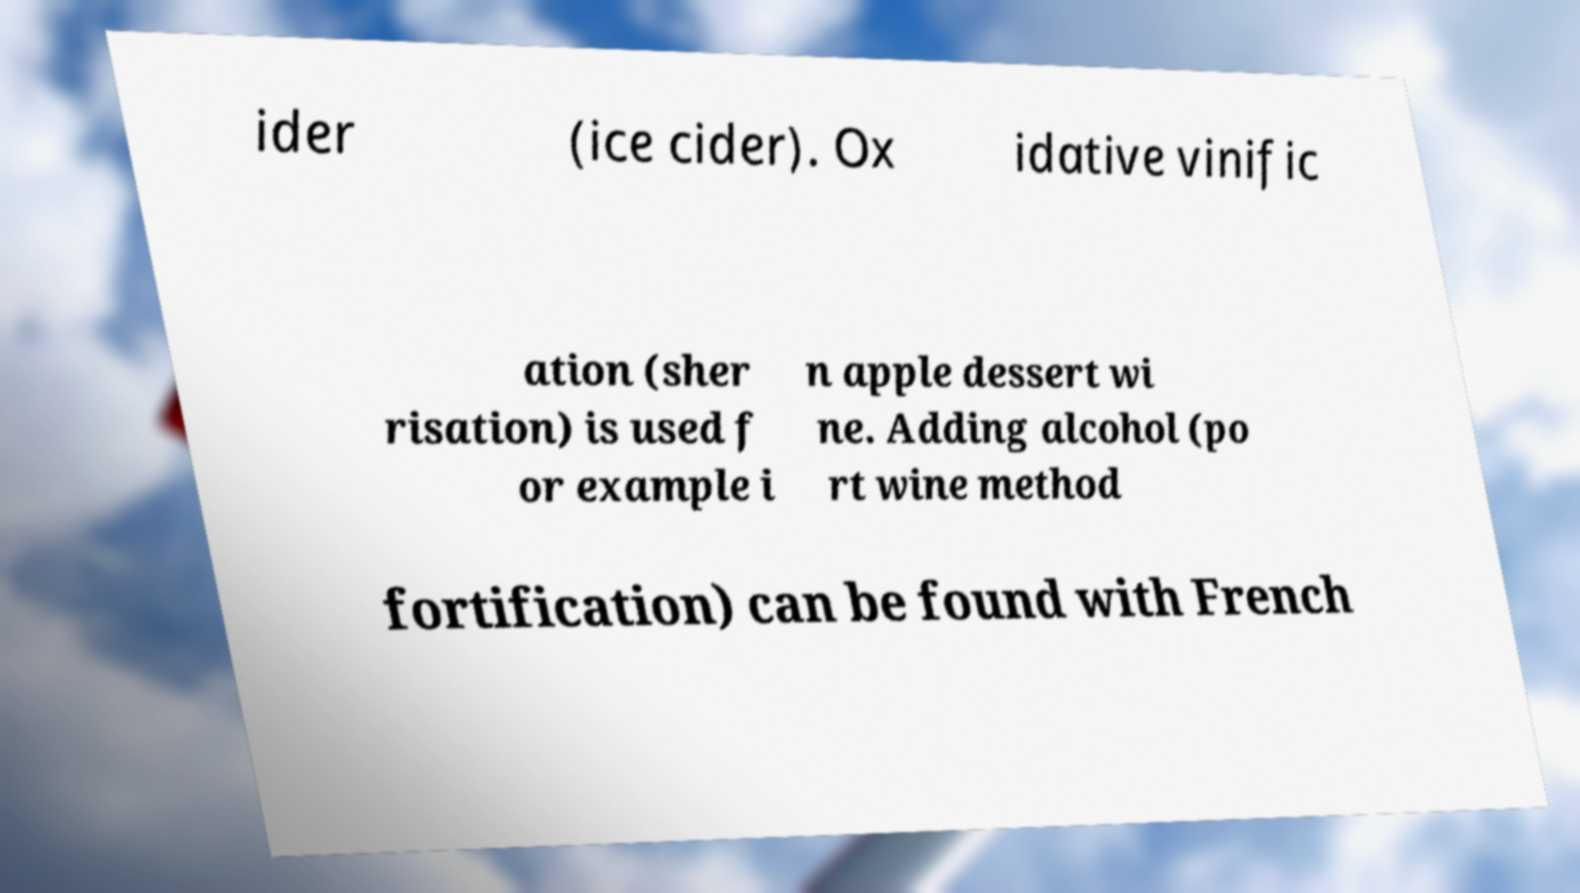I need the written content from this picture converted into text. Can you do that? ider (ice cider). Ox idative vinific ation (sher risation) is used f or example i n apple dessert wi ne. Adding alcohol (po rt wine method fortification) can be found with French 